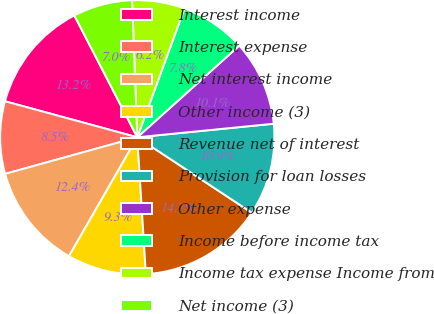<chart> <loc_0><loc_0><loc_500><loc_500><pie_chart><fcel>Interest income<fcel>Interest expense<fcel>Net interest income<fcel>Other income (3)<fcel>Revenue net of interest<fcel>Provision for loan losses<fcel>Other expense<fcel>Income before income tax<fcel>Income tax expense Income from<fcel>Net income (3)<nl><fcel>13.18%<fcel>8.53%<fcel>12.4%<fcel>9.3%<fcel>14.73%<fcel>10.85%<fcel>10.08%<fcel>7.75%<fcel>6.2%<fcel>6.98%<nl></chart> 